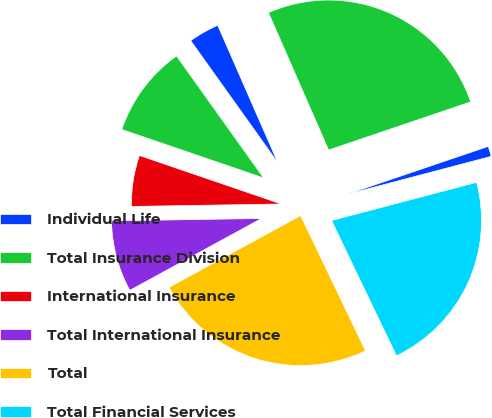Convert chart to OTSL. <chart><loc_0><loc_0><loc_500><loc_500><pie_chart><fcel>Individual Life<fcel>Total Insurance Division<fcel>International Insurance<fcel>Total International Insurance<fcel>Total<fcel>Total Financial Services<fcel>Closed Block Business<fcel>Total per Consolidated<nl><fcel>3.3%<fcel>9.89%<fcel>5.5%<fcel>7.69%<fcel>24.17%<fcel>21.98%<fcel>1.1%<fcel>26.37%<nl></chart> 